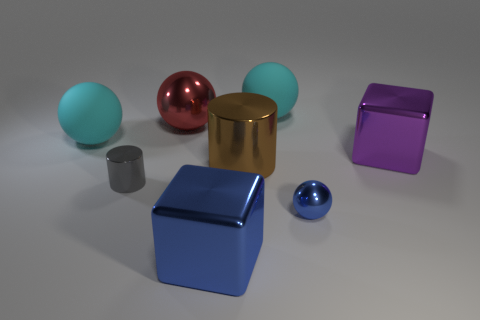Can you describe the atmosphere or mood conveyed by this arrangement? The image presents a calm and composed atmosphere. The combination of soft lighting and the assortment of matte and metallic objects creates a visually pleasing contrast that is soothing to observe. The simplicity of the scene and the lack of any dynamic action evoke a sense of stillness and tranquility. 